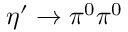<formula> <loc_0><loc_0><loc_500><loc_500>\eta ^ { \prime } \rightarrow \pi ^ { 0 } \pi ^ { 0 }</formula> 